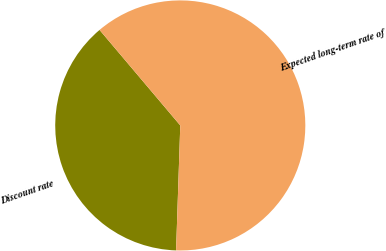Convert chart. <chart><loc_0><loc_0><loc_500><loc_500><pie_chart><fcel>Discount rate<fcel>Expected long-term rate of<nl><fcel>38.3%<fcel>61.7%<nl></chart> 